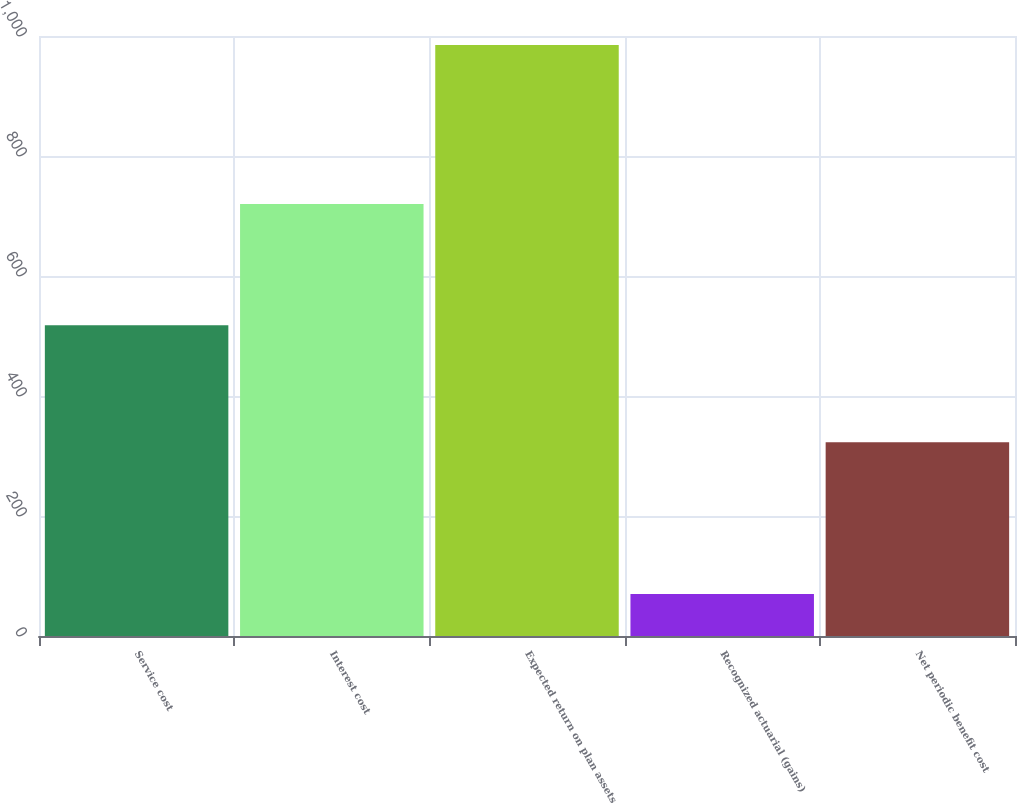<chart> <loc_0><loc_0><loc_500><loc_500><bar_chart><fcel>Service cost<fcel>Interest cost<fcel>Expected return on plan assets<fcel>Recognized actuarial (gains)<fcel>Net periodic benefit cost<nl><fcel>518<fcel>720<fcel>985<fcel>70<fcel>323<nl></chart> 